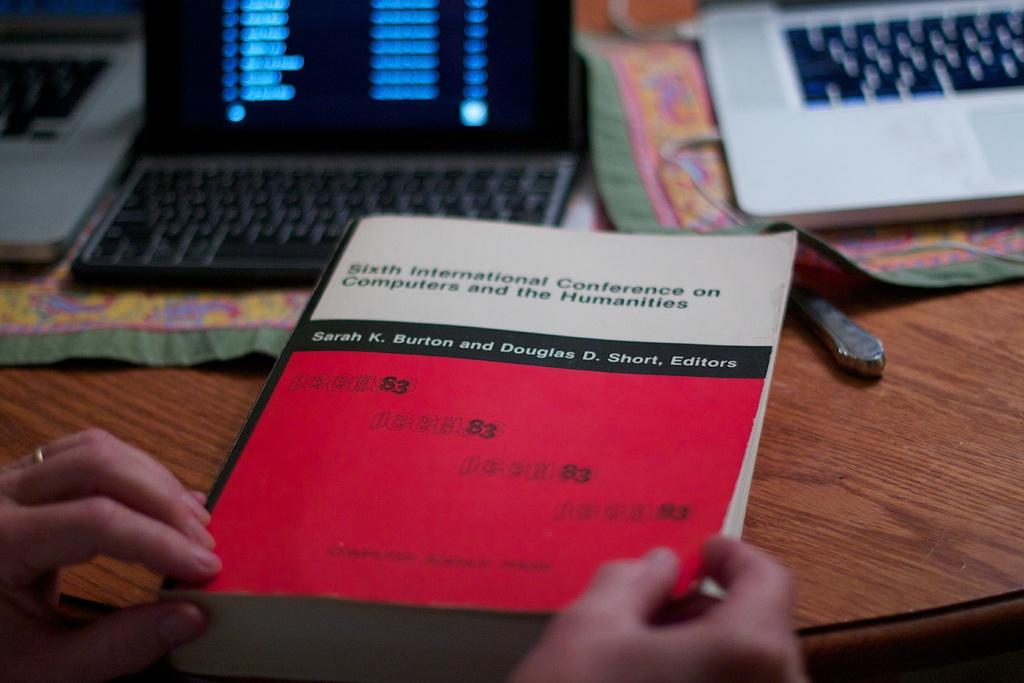<image>
Write a terse but informative summary of the picture. Sarah K Burton wrote a book with Douglas D Short 